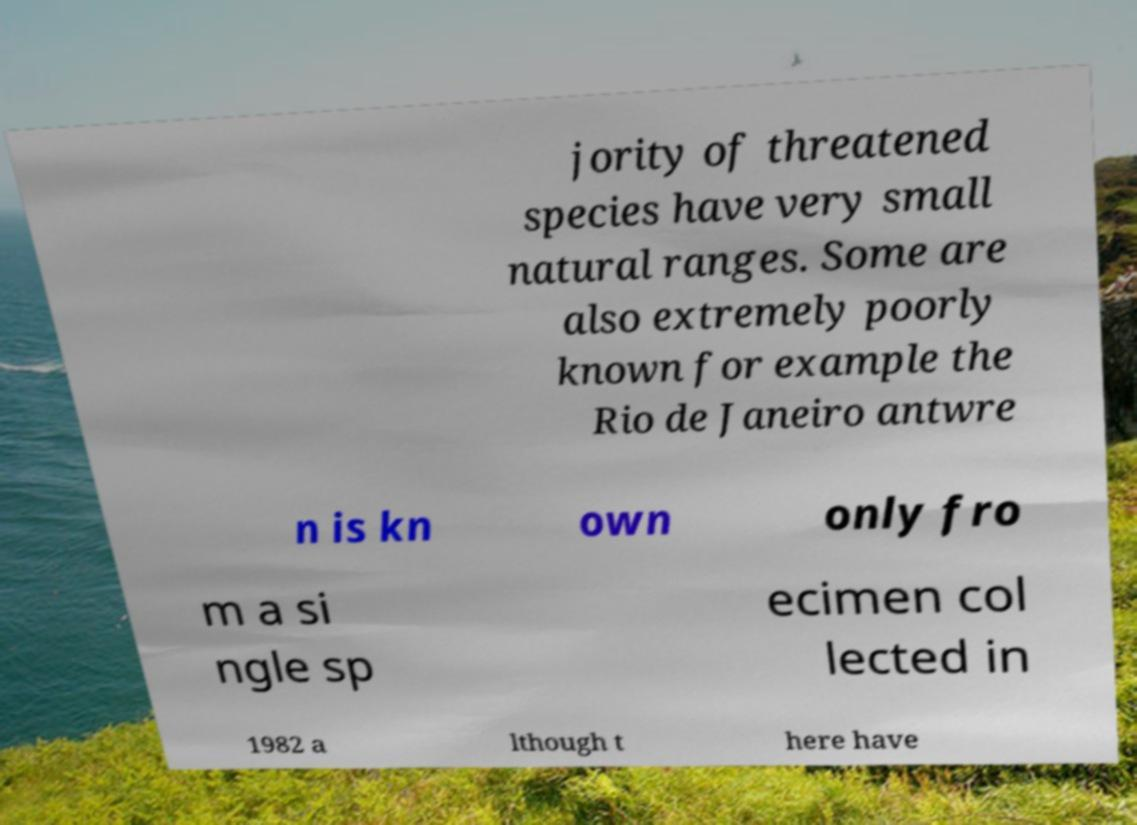There's text embedded in this image that I need extracted. Can you transcribe it verbatim? jority of threatened species have very small natural ranges. Some are also extremely poorly known for example the Rio de Janeiro antwre n is kn own only fro m a si ngle sp ecimen col lected in 1982 a lthough t here have 